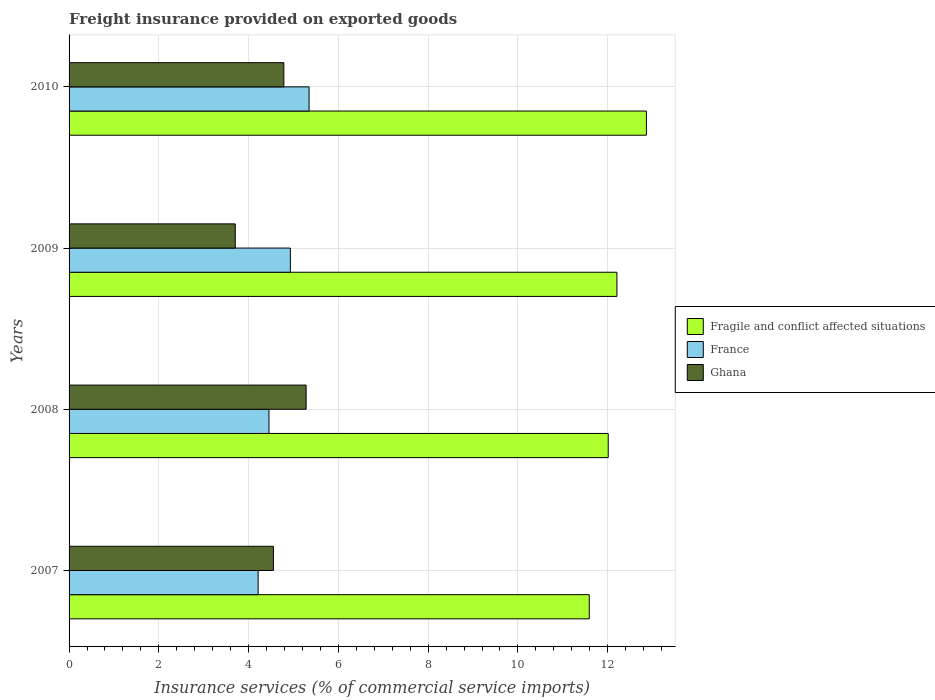How many bars are there on the 3rd tick from the top?
Your answer should be compact. 3. How many bars are there on the 2nd tick from the bottom?
Your answer should be compact. 3. In how many cases, is the number of bars for a given year not equal to the number of legend labels?
Keep it short and to the point. 0. What is the freight insurance provided on exported goods in Ghana in 2009?
Keep it short and to the point. 3.7. Across all years, what is the maximum freight insurance provided on exported goods in Ghana?
Your response must be concise. 5.28. Across all years, what is the minimum freight insurance provided on exported goods in France?
Your answer should be very brief. 4.21. In which year was the freight insurance provided on exported goods in France minimum?
Provide a short and direct response. 2007. What is the total freight insurance provided on exported goods in France in the graph?
Keep it short and to the point. 18.94. What is the difference between the freight insurance provided on exported goods in Ghana in 2007 and that in 2010?
Give a very brief answer. -0.23. What is the difference between the freight insurance provided on exported goods in Fragile and conflict affected situations in 2010 and the freight insurance provided on exported goods in France in 2009?
Give a very brief answer. 7.93. What is the average freight insurance provided on exported goods in Ghana per year?
Give a very brief answer. 4.58. In the year 2007, what is the difference between the freight insurance provided on exported goods in Fragile and conflict affected situations and freight insurance provided on exported goods in Ghana?
Your answer should be very brief. 7.04. In how many years, is the freight insurance provided on exported goods in Ghana greater than 5.2 %?
Make the answer very short. 1. What is the ratio of the freight insurance provided on exported goods in France in 2009 to that in 2010?
Give a very brief answer. 0.92. What is the difference between the highest and the second highest freight insurance provided on exported goods in France?
Your answer should be compact. 0.42. What is the difference between the highest and the lowest freight insurance provided on exported goods in France?
Your answer should be very brief. 1.13. What does the 1st bar from the top in 2008 represents?
Give a very brief answer. Ghana. What does the 3rd bar from the bottom in 2010 represents?
Ensure brevity in your answer.  Ghana. How many bars are there?
Provide a succinct answer. 12. What is the difference between two consecutive major ticks on the X-axis?
Provide a short and direct response. 2. Does the graph contain any zero values?
Ensure brevity in your answer.  No. How many legend labels are there?
Offer a terse response. 3. What is the title of the graph?
Offer a terse response. Freight insurance provided on exported goods. Does "Korea (Republic)" appear as one of the legend labels in the graph?
Ensure brevity in your answer.  No. What is the label or title of the X-axis?
Make the answer very short. Insurance services (% of commercial service imports). What is the Insurance services (% of commercial service imports) of Fragile and conflict affected situations in 2007?
Offer a terse response. 11.59. What is the Insurance services (% of commercial service imports) in France in 2007?
Your answer should be compact. 4.21. What is the Insurance services (% of commercial service imports) in Ghana in 2007?
Make the answer very short. 4.55. What is the Insurance services (% of commercial service imports) of Fragile and conflict affected situations in 2008?
Your answer should be compact. 12.01. What is the Insurance services (% of commercial service imports) of France in 2008?
Your response must be concise. 4.45. What is the Insurance services (% of commercial service imports) of Ghana in 2008?
Ensure brevity in your answer.  5.28. What is the Insurance services (% of commercial service imports) in Fragile and conflict affected situations in 2009?
Provide a short and direct response. 12.21. What is the Insurance services (% of commercial service imports) of France in 2009?
Give a very brief answer. 4.93. What is the Insurance services (% of commercial service imports) of Ghana in 2009?
Your answer should be very brief. 3.7. What is the Insurance services (% of commercial service imports) in Fragile and conflict affected situations in 2010?
Make the answer very short. 12.86. What is the Insurance services (% of commercial service imports) in France in 2010?
Make the answer very short. 5.35. What is the Insurance services (% of commercial service imports) in Ghana in 2010?
Ensure brevity in your answer.  4.79. Across all years, what is the maximum Insurance services (% of commercial service imports) in Fragile and conflict affected situations?
Provide a short and direct response. 12.86. Across all years, what is the maximum Insurance services (% of commercial service imports) in France?
Your answer should be very brief. 5.35. Across all years, what is the maximum Insurance services (% of commercial service imports) in Ghana?
Keep it short and to the point. 5.28. Across all years, what is the minimum Insurance services (% of commercial service imports) in Fragile and conflict affected situations?
Provide a succinct answer. 11.59. Across all years, what is the minimum Insurance services (% of commercial service imports) in France?
Your answer should be compact. 4.21. Across all years, what is the minimum Insurance services (% of commercial service imports) of Ghana?
Provide a short and direct response. 3.7. What is the total Insurance services (% of commercial service imports) in Fragile and conflict affected situations in the graph?
Make the answer very short. 48.67. What is the total Insurance services (% of commercial service imports) of France in the graph?
Give a very brief answer. 18.94. What is the total Insurance services (% of commercial service imports) in Ghana in the graph?
Offer a very short reply. 18.32. What is the difference between the Insurance services (% of commercial service imports) of Fragile and conflict affected situations in 2007 and that in 2008?
Offer a very short reply. -0.42. What is the difference between the Insurance services (% of commercial service imports) of France in 2007 and that in 2008?
Ensure brevity in your answer.  -0.24. What is the difference between the Insurance services (% of commercial service imports) of Ghana in 2007 and that in 2008?
Your answer should be compact. -0.73. What is the difference between the Insurance services (% of commercial service imports) in Fragile and conflict affected situations in 2007 and that in 2009?
Keep it short and to the point. -0.62. What is the difference between the Insurance services (% of commercial service imports) of France in 2007 and that in 2009?
Your answer should be very brief. -0.72. What is the difference between the Insurance services (% of commercial service imports) of Ghana in 2007 and that in 2009?
Your response must be concise. 0.85. What is the difference between the Insurance services (% of commercial service imports) in Fragile and conflict affected situations in 2007 and that in 2010?
Offer a very short reply. -1.27. What is the difference between the Insurance services (% of commercial service imports) in France in 2007 and that in 2010?
Make the answer very short. -1.13. What is the difference between the Insurance services (% of commercial service imports) of Ghana in 2007 and that in 2010?
Make the answer very short. -0.23. What is the difference between the Insurance services (% of commercial service imports) of Fragile and conflict affected situations in 2008 and that in 2009?
Provide a short and direct response. -0.19. What is the difference between the Insurance services (% of commercial service imports) in France in 2008 and that in 2009?
Offer a very short reply. -0.48. What is the difference between the Insurance services (% of commercial service imports) in Ghana in 2008 and that in 2009?
Ensure brevity in your answer.  1.58. What is the difference between the Insurance services (% of commercial service imports) in Fragile and conflict affected situations in 2008 and that in 2010?
Your response must be concise. -0.85. What is the difference between the Insurance services (% of commercial service imports) in France in 2008 and that in 2010?
Offer a very short reply. -0.89. What is the difference between the Insurance services (% of commercial service imports) in Ghana in 2008 and that in 2010?
Offer a very short reply. 0.5. What is the difference between the Insurance services (% of commercial service imports) of Fragile and conflict affected situations in 2009 and that in 2010?
Your answer should be very brief. -0.66. What is the difference between the Insurance services (% of commercial service imports) in France in 2009 and that in 2010?
Your answer should be compact. -0.42. What is the difference between the Insurance services (% of commercial service imports) in Ghana in 2009 and that in 2010?
Make the answer very short. -1.08. What is the difference between the Insurance services (% of commercial service imports) in Fragile and conflict affected situations in 2007 and the Insurance services (% of commercial service imports) in France in 2008?
Ensure brevity in your answer.  7.14. What is the difference between the Insurance services (% of commercial service imports) of Fragile and conflict affected situations in 2007 and the Insurance services (% of commercial service imports) of Ghana in 2008?
Ensure brevity in your answer.  6.31. What is the difference between the Insurance services (% of commercial service imports) in France in 2007 and the Insurance services (% of commercial service imports) in Ghana in 2008?
Provide a short and direct response. -1.07. What is the difference between the Insurance services (% of commercial service imports) in Fragile and conflict affected situations in 2007 and the Insurance services (% of commercial service imports) in France in 2009?
Offer a terse response. 6.66. What is the difference between the Insurance services (% of commercial service imports) of Fragile and conflict affected situations in 2007 and the Insurance services (% of commercial service imports) of Ghana in 2009?
Provide a succinct answer. 7.89. What is the difference between the Insurance services (% of commercial service imports) in France in 2007 and the Insurance services (% of commercial service imports) in Ghana in 2009?
Give a very brief answer. 0.51. What is the difference between the Insurance services (% of commercial service imports) of Fragile and conflict affected situations in 2007 and the Insurance services (% of commercial service imports) of France in 2010?
Keep it short and to the point. 6.24. What is the difference between the Insurance services (% of commercial service imports) in Fragile and conflict affected situations in 2007 and the Insurance services (% of commercial service imports) in Ghana in 2010?
Your answer should be very brief. 6.8. What is the difference between the Insurance services (% of commercial service imports) of France in 2007 and the Insurance services (% of commercial service imports) of Ghana in 2010?
Provide a succinct answer. -0.57. What is the difference between the Insurance services (% of commercial service imports) in Fragile and conflict affected situations in 2008 and the Insurance services (% of commercial service imports) in France in 2009?
Offer a very short reply. 7.08. What is the difference between the Insurance services (% of commercial service imports) of Fragile and conflict affected situations in 2008 and the Insurance services (% of commercial service imports) of Ghana in 2009?
Offer a terse response. 8.31. What is the difference between the Insurance services (% of commercial service imports) of France in 2008 and the Insurance services (% of commercial service imports) of Ghana in 2009?
Your answer should be compact. 0.75. What is the difference between the Insurance services (% of commercial service imports) in Fragile and conflict affected situations in 2008 and the Insurance services (% of commercial service imports) in France in 2010?
Make the answer very short. 6.66. What is the difference between the Insurance services (% of commercial service imports) in Fragile and conflict affected situations in 2008 and the Insurance services (% of commercial service imports) in Ghana in 2010?
Give a very brief answer. 7.23. What is the difference between the Insurance services (% of commercial service imports) in France in 2008 and the Insurance services (% of commercial service imports) in Ghana in 2010?
Your answer should be very brief. -0.33. What is the difference between the Insurance services (% of commercial service imports) in Fragile and conflict affected situations in 2009 and the Insurance services (% of commercial service imports) in France in 2010?
Provide a short and direct response. 6.86. What is the difference between the Insurance services (% of commercial service imports) of Fragile and conflict affected situations in 2009 and the Insurance services (% of commercial service imports) of Ghana in 2010?
Give a very brief answer. 7.42. What is the difference between the Insurance services (% of commercial service imports) of France in 2009 and the Insurance services (% of commercial service imports) of Ghana in 2010?
Offer a very short reply. 0.15. What is the average Insurance services (% of commercial service imports) of Fragile and conflict affected situations per year?
Offer a very short reply. 12.17. What is the average Insurance services (% of commercial service imports) in France per year?
Give a very brief answer. 4.74. What is the average Insurance services (% of commercial service imports) of Ghana per year?
Your answer should be very brief. 4.58. In the year 2007, what is the difference between the Insurance services (% of commercial service imports) of Fragile and conflict affected situations and Insurance services (% of commercial service imports) of France?
Offer a very short reply. 7.38. In the year 2007, what is the difference between the Insurance services (% of commercial service imports) in Fragile and conflict affected situations and Insurance services (% of commercial service imports) in Ghana?
Your response must be concise. 7.04. In the year 2007, what is the difference between the Insurance services (% of commercial service imports) of France and Insurance services (% of commercial service imports) of Ghana?
Your answer should be very brief. -0.34. In the year 2008, what is the difference between the Insurance services (% of commercial service imports) of Fragile and conflict affected situations and Insurance services (% of commercial service imports) of France?
Ensure brevity in your answer.  7.56. In the year 2008, what is the difference between the Insurance services (% of commercial service imports) in Fragile and conflict affected situations and Insurance services (% of commercial service imports) in Ghana?
Offer a terse response. 6.73. In the year 2008, what is the difference between the Insurance services (% of commercial service imports) in France and Insurance services (% of commercial service imports) in Ghana?
Ensure brevity in your answer.  -0.83. In the year 2009, what is the difference between the Insurance services (% of commercial service imports) in Fragile and conflict affected situations and Insurance services (% of commercial service imports) in France?
Make the answer very short. 7.28. In the year 2009, what is the difference between the Insurance services (% of commercial service imports) in Fragile and conflict affected situations and Insurance services (% of commercial service imports) in Ghana?
Your response must be concise. 8.5. In the year 2009, what is the difference between the Insurance services (% of commercial service imports) of France and Insurance services (% of commercial service imports) of Ghana?
Ensure brevity in your answer.  1.23. In the year 2010, what is the difference between the Insurance services (% of commercial service imports) of Fragile and conflict affected situations and Insurance services (% of commercial service imports) of France?
Offer a terse response. 7.52. In the year 2010, what is the difference between the Insurance services (% of commercial service imports) of Fragile and conflict affected situations and Insurance services (% of commercial service imports) of Ghana?
Your answer should be compact. 8.08. In the year 2010, what is the difference between the Insurance services (% of commercial service imports) of France and Insurance services (% of commercial service imports) of Ghana?
Ensure brevity in your answer.  0.56. What is the ratio of the Insurance services (% of commercial service imports) in Fragile and conflict affected situations in 2007 to that in 2008?
Provide a succinct answer. 0.96. What is the ratio of the Insurance services (% of commercial service imports) in France in 2007 to that in 2008?
Give a very brief answer. 0.95. What is the ratio of the Insurance services (% of commercial service imports) of Ghana in 2007 to that in 2008?
Provide a short and direct response. 0.86. What is the ratio of the Insurance services (% of commercial service imports) of Fragile and conflict affected situations in 2007 to that in 2009?
Your response must be concise. 0.95. What is the ratio of the Insurance services (% of commercial service imports) of France in 2007 to that in 2009?
Give a very brief answer. 0.85. What is the ratio of the Insurance services (% of commercial service imports) of Ghana in 2007 to that in 2009?
Provide a succinct answer. 1.23. What is the ratio of the Insurance services (% of commercial service imports) in Fragile and conflict affected situations in 2007 to that in 2010?
Ensure brevity in your answer.  0.9. What is the ratio of the Insurance services (% of commercial service imports) in France in 2007 to that in 2010?
Your answer should be compact. 0.79. What is the ratio of the Insurance services (% of commercial service imports) of Ghana in 2007 to that in 2010?
Keep it short and to the point. 0.95. What is the ratio of the Insurance services (% of commercial service imports) of Fragile and conflict affected situations in 2008 to that in 2009?
Your response must be concise. 0.98. What is the ratio of the Insurance services (% of commercial service imports) in France in 2008 to that in 2009?
Your answer should be compact. 0.9. What is the ratio of the Insurance services (% of commercial service imports) in Ghana in 2008 to that in 2009?
Your answer should be compact. 1.43. What is the ratio of the Insurance services (% of commercial service imports) of Fragile and conflict affected situations in 2008 to that in 2010?
Offer a terse response. 0.93. What is the ratio of the Insurance services (% of commercial service imports) of France in 2008 to that in 2010?
Your response must be concise. 0.83. What is the ratio of the Insurance services (% of commercial service imports) of Ghana in 2008 to that in 2010?
Offer a terse response. 1.1. What is the ratio of the Insurance services (% of commercial service imports) in Fragile and conflict affected situations in 2009 to that in 2010?
Provide a short and direct response. 0.95. What is the ratio of the Insurance services (% of commercial service imports) in France in 2009 to that in 2010?
Make the answer very short. 0.92. What is the ratio of the Insurance services (% of commercial service imports) of Ghana in 2009 to that in 2010?
Offer a terse response. 0.77. What is the difference between the highest and the second highest Insurance services (% of commercial service imports) in Fragile and conflict affected situations?
Ensure brevity in your answer.  0.66. What is the difference between the highest and the second highest Insurance services (% of commercial service imports) of France?
Ensure brevity in your answer.  0.42. What is the difference between the highest and the second highest Insurance services (% of commercial service imports) of Ghana?
Make the answer very short. 0.5. What is the difference between the highest and the lowest Insurance services (% of commercial service imports) of Fragile and conflict affected situations?
Keep it short and to the point. 1.27. What is the difference between the highest and the lowest Insurance services (% of commercial service imports) in France?
Provide a succinct answer. 1.13. What is the difference between the highest and the lowest Insurance services (% of commercial service imports) of Ghana?
Give a very brief answer. 1.58. 